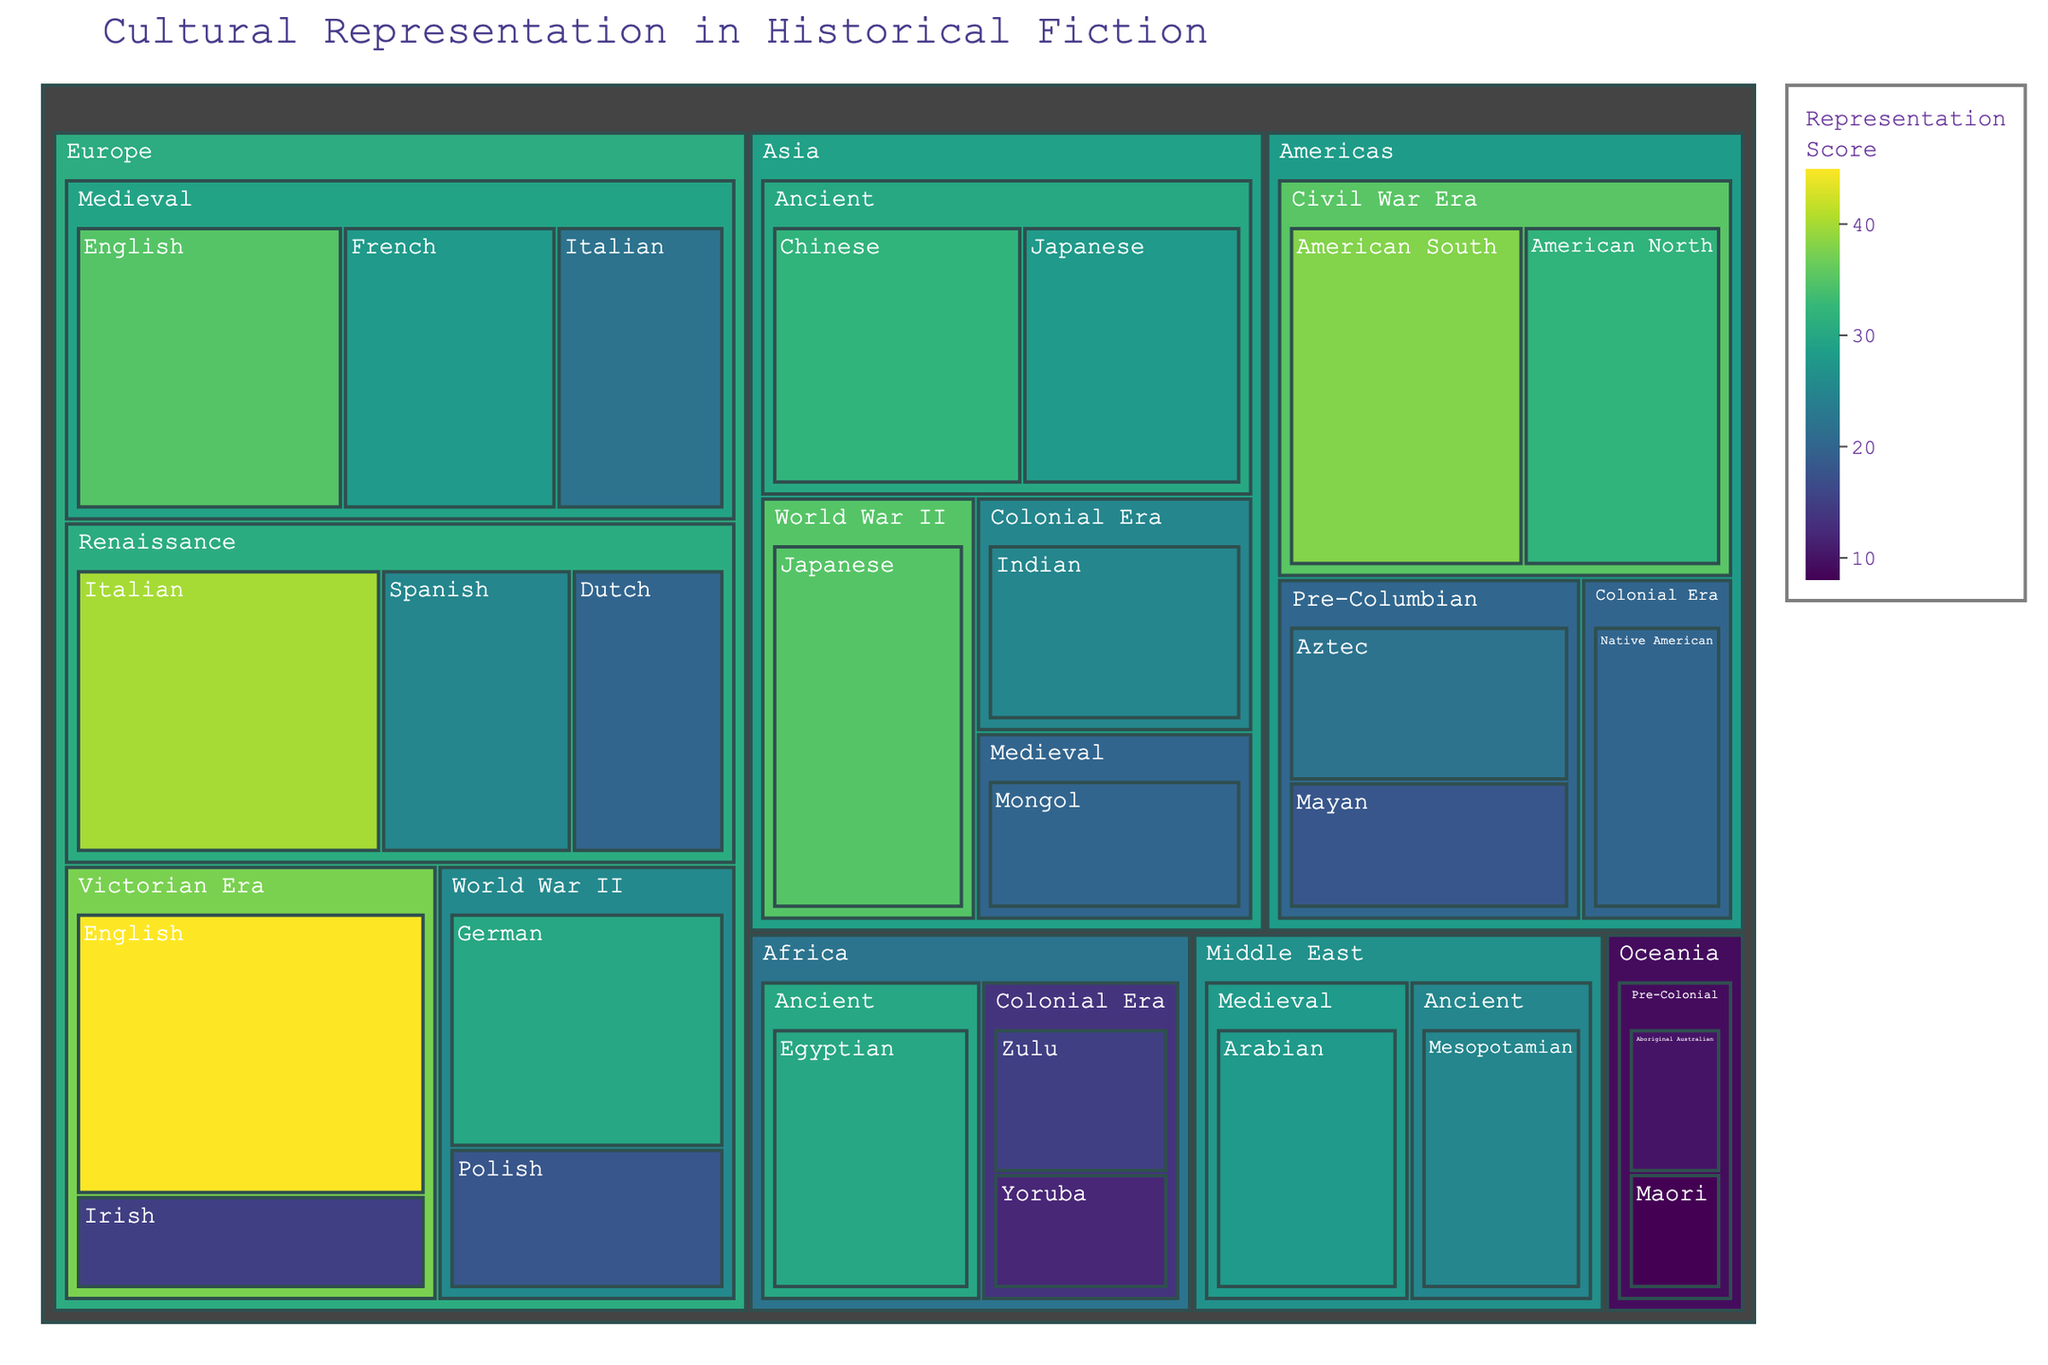What's the most represented culture in the "Medieval" time period? Locate the "Medieval" time period in each region. Analyze the representation scores of English, French, Italian under Europe; and Mongol under Asia. Compare all to find the highest.
Answer: English How many cultures are represented in the "World War II" time period? Identify the "World War II" time period in each region, counting all unique cultures: German and Polish for Europe, Japanese for Asia.
Answer: 3 Which region has the highest total representation score? Sum the scores under each region individually: Europe, Asia, Americas, Africa, Middle East, Oceania. Compare totals to find the highest.
Answer: Europe Out of the Victorian Era representations, which culture has the lowest score? Identify the "Victorian Era" period under Europe. Compare the representation scores for English and Irish cultures, selecting the lowest.
Answer: Irish What is the average representation score for "Ancient" time period cultures in Asia? Locate the "Ancient" time period under Asia. Average the representation scores for Chinese and Japanese cultures: (32 + 28) / 2.
Answer: 30 Which two cultures have the closest representation scores within the "Pre-Columbian" time period in the Americas? Locate the "Pre-Columbian" time period under Americas. Compare the scores for Aztec and Mayan, finding the closest values.
Answer: Aztec and Mayan Does Africa or the Middle East have more representation in the "Ancient" time period? Identify the "Ancient" time period in both regions. Compare the sum of representation scores for Egyptian in Africa and Mesopotamian in Middle East.
Answer: Africa Which culture has a higher representation score: "Victorian Era" English or "World War II" Japanese? Compare the representation scores for Victorian Era English (45) and World War II Japanese (35).
Answer: Victorian Era English How many cultures are represented in total across all regions and time periods? Count all unique cultural entries provided in the dataset.
Answer: 26 